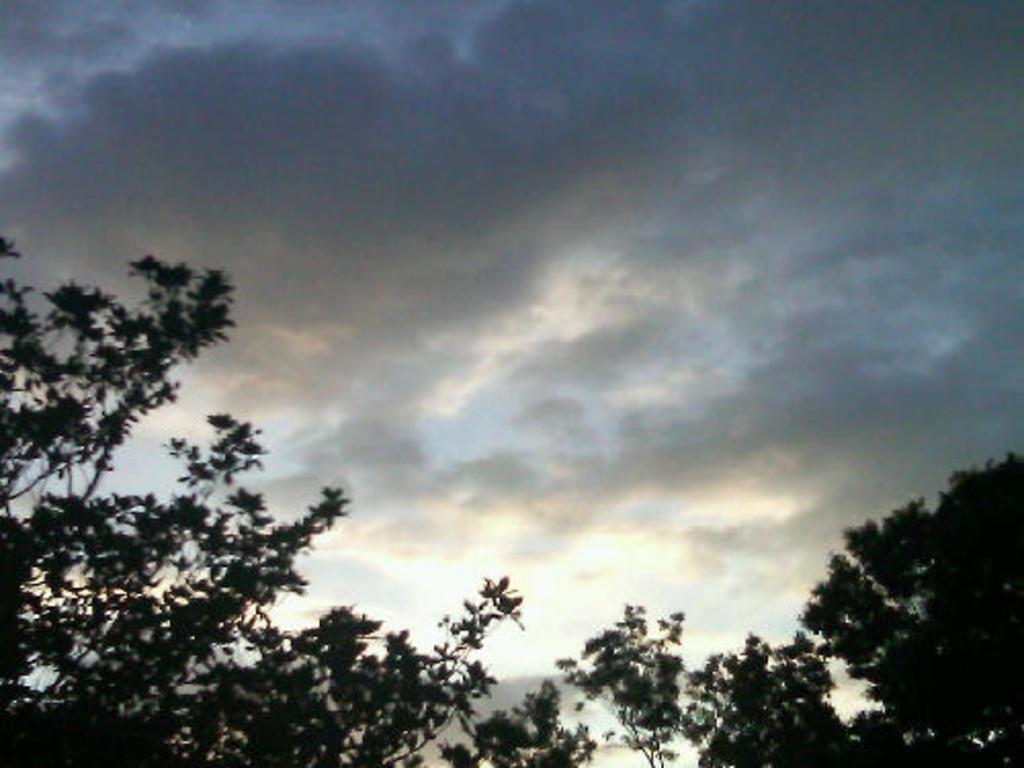What type of vegetation can be seen in the image? There are trees in the image. What is the condition of the sky in the image? The sky is cloudy in the image. Where is the shelf located in the image? There is no shelf present in the image. How many cakes are being tricked in the image? There are no cakes or trickery depicted in the image. 